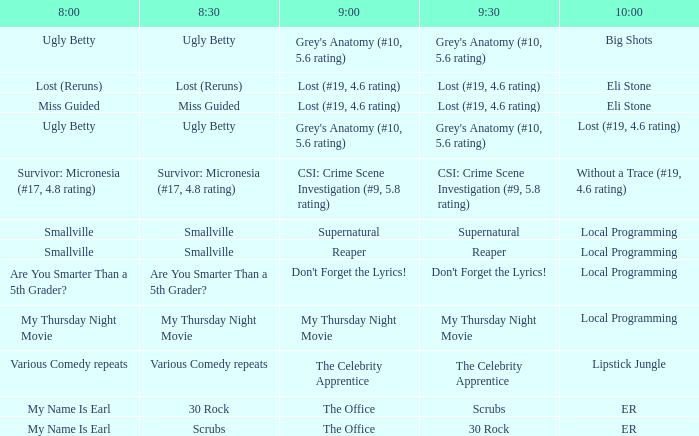What is at 10:00 when at 9:00 it is lost (#19, 4.6 rating) and at 8:30 it is lost (reruns)? Eli Stone. 